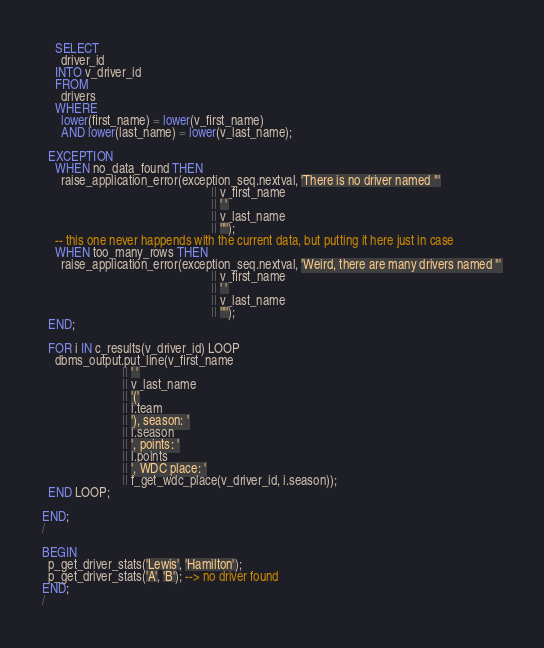Convert code to text. <code><loc_0><loc_0><loc_500><loc_500><_SQL_>    SELECT
      driver_id
    INTO v_driver_id
    FROM
      drivers
    WHERE
      lower(first_name) = lower(v_first_name)
      AND lower(last_name) = lower(v_last_name);

  EXCEPTION
    WHEN no_data_found THEN
      raise_application_error(exception_seq.nextval, 'There is no driver named "'
                                                     || v_first_name
                                                     || ' '
                                                     || v_last_name
                                                     || '"');
    -- this one never happends with the current data, but putting it here just in case
    WHEN too_many_rows THEN
      raise_application_error(exception_seq.nextval, 'Weird, there are many drivers named "'
                                                     || v_first_name
                                                     || ' '
                                                     || v_last_name
                                                     || '"');
  END;

  FOR i IN c_results(v_driver_id) LOOP
    dbms_output.put_line(v_first_name
                         || ' '
                         || v_last_name
                         || '('
                         || i.team
                         || '), season: '
                         || i.season
                         || ', points: '
                         || i.points
                         || ', WDC place: '
                         || f_get_wdc_place(v_driver_id, i.season));
  END LOOP;

END;
/

BEGIN
  p_get_driver_stats('Lewis', 'Hamilton');
  p_get_driver_stats('A', 'B'); --> no driver found
END;
/
</code> 